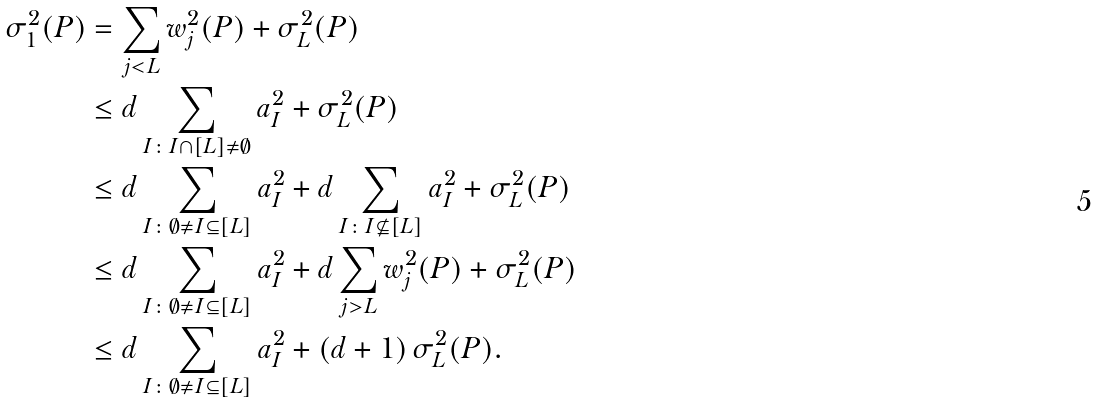Convert formula to latex. <formula><loc_0><loc_0><loc_500><loc_500>\sigma ^ { 2 } _ { 1 } ( P ) & = \sum _ { j < L } w ^ { 2 } _ { j } ( P ) + \sigma ^ { 2 } _ { L } ( P ) \\ & \leq d \sum _ { I \colon I \cap [ L ] \neq \emptyset } a _ { I } ^ { 2 } + \sigma ^ { 2 } _ { L } ( P ) \\ & \leq d \sum _ { I \colon \emptyset \neq I \subseteq [ L ] } a _ { I } ^ { 2 } + d \sum _ { I \colon I \not \subseteq [ L ] } a _ { I } ^ { 2 } + \sigma ^ { 2 } _ { L } ( P ) \\ & \leq d \sum _ { I \colon \emptyset \neq I \subseteq [ L ] } a _ { I } ^ { 2 } + d \sum _ { j > L } w ^ { 2 } _ { j } ( P ) + \sigma ^ { 2 } _ { L } ( P ) \\ & \leq d \sum _ { I \colon \emptyset \neq I \subseteq [ L ] } a _ { I } ^ { 2 } + ( d + 1 ) \, \sigma ^ { 2 } _ { L } ( P ) .</formula> 